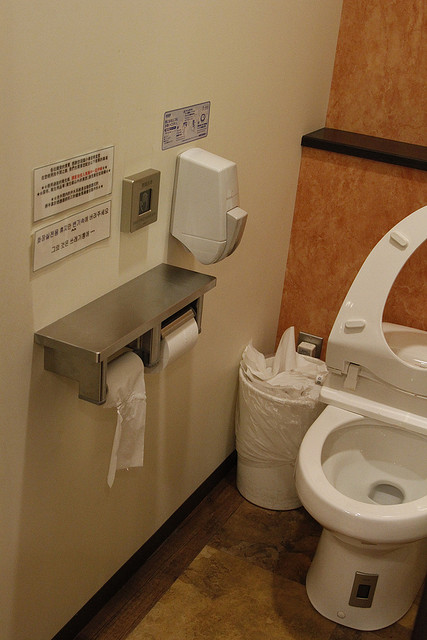<image>What word do you see clearly on the sign over the toilet? I am unsure what the sign over the toilet says. It may say 'wash hands' or 'flush', but it's also possible there is no word. What word do you see clearly on the sign over the toilet? I don't know what word is clearly seen on the sign over the toilet. It can be 'wash hands', 'japanese', 'flush' or 'in chinese'. 